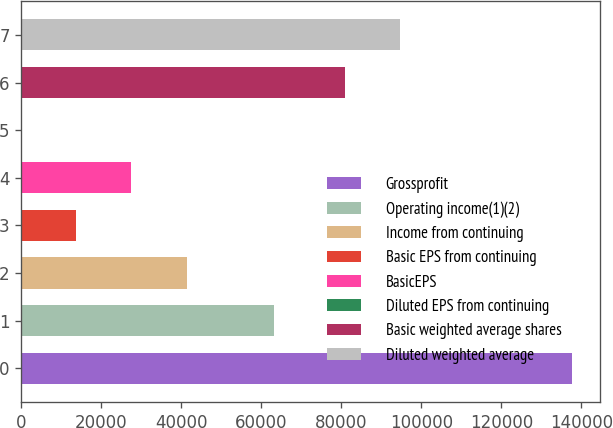Convert chart. <chart><loc_0><loc_0><loc_500><loc_500><bar_chart><fcel>Grossprofit<fcel>Operating income(1)(2)<fcel>Income from continuing<fcel>Basic EPS from continuing<fcel>BasicEPS<fcel>Diluted EPS from continuing<fcel>Basic weighted average shares<fcel>Diluted weighted average<nl><fcel>137665<fcel>63148<fcel>41299.8<fcel>13766.9<fcel>27533.4<fcel>0.47<fcel>80832<fcel>94598.4<nl></chart> 